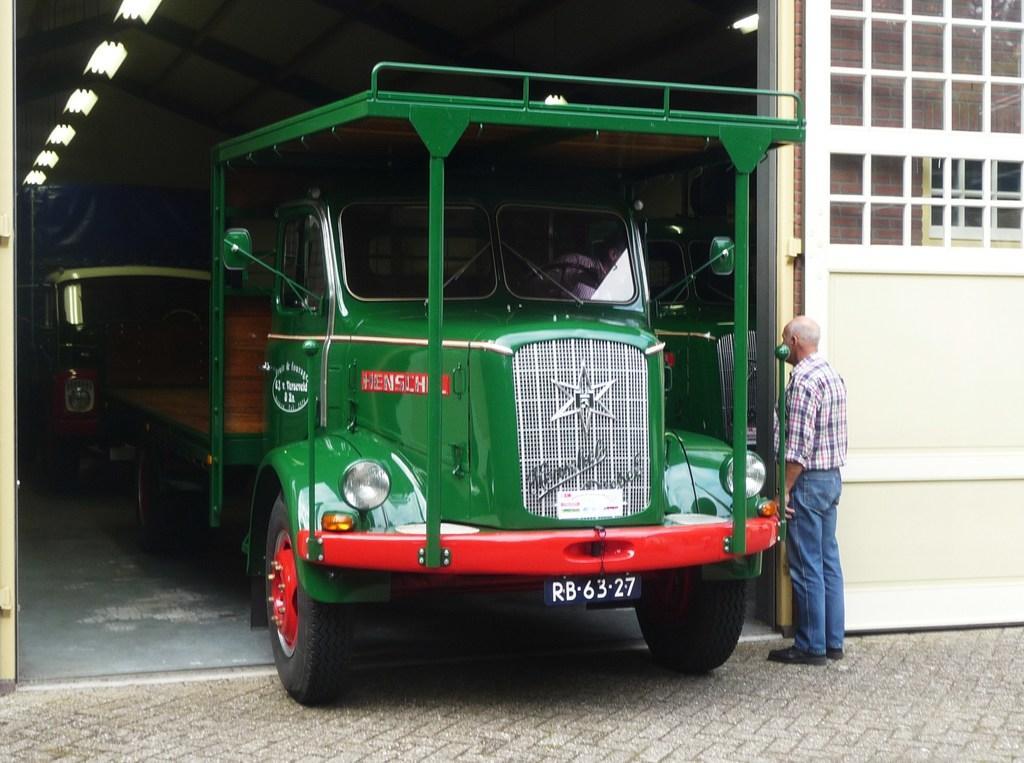Can you describe this image briefly? In this image, I can see a person standing. I think these are the two trucks. At the top of the image, I can see the ceiling lights, which are attached to the ceiling. On the right side of the image, that looks like an iron gate. 